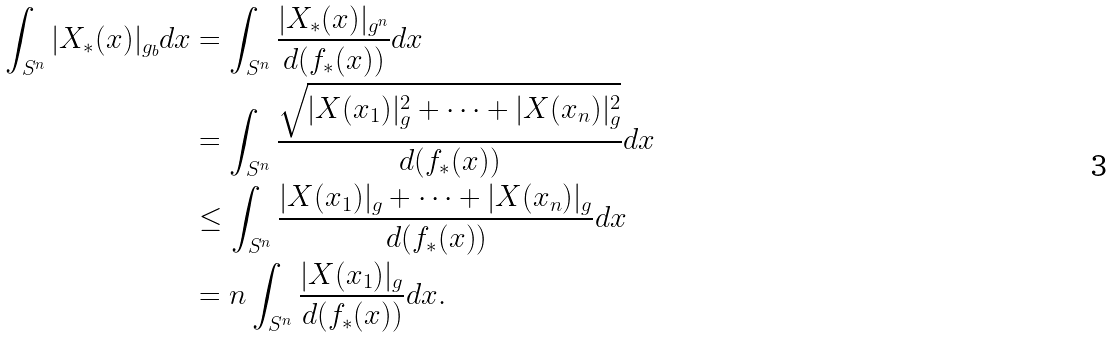<formula> <loc_0><loc_0><loc_500><loc_500>\int _ { S ^ { n } } | X _ { * } ( x ) | _ { g _ { b } } d x & = \int _ { S ^ { n } } \frac { | X _ { * } ( x ) | _ { g ^ { n } } } { d ( f _ { * } ( x ) ) } d x \\ & = \int _ { S ^ { n } } \frac { \sqrt { | X ( x _ { 1 } ) | ^ { 2 } _ { g } + \dots + | X ( x _ { n } ) | ^ { 2 } _ { g } } } { d ( f _ { * } ( x ) ) } d x \\ & \leq \int _ { S ^ { n } } \frac { | X ( x _ { 1 } ) | _ { g } + \dots + | X ( x _ { n } ) | _ { g } } { d ( f _ { * } ( x ) ) } d x \\ & = n \int _ { S ^ { n } } \frac { | X ( x _ { 1 } ) | _ { g } } { d ( f _ { * } ( x ) ) } d x . \\</formula> 